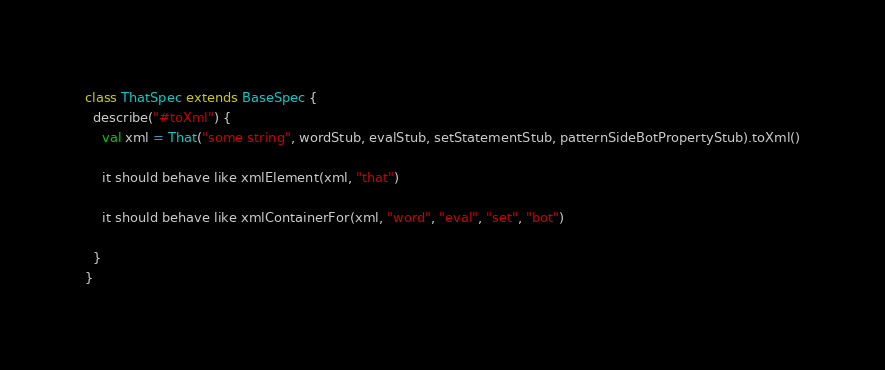<code> <loc_0><loc_0><loc_500><loc_500><_Scala_>
class ThatSpec extends BaseSpec {
  describe("#toXml") {
    val xml = That("some string", wordStub, evalStub, setStatementStub, patternSideBotPropertyStub).toXml()

    it should behave like xmlElement(xml, "that")

    it should behave like xmlContainerFor(xml, "word", "eval", "set", "bot")

  }
}</code> 